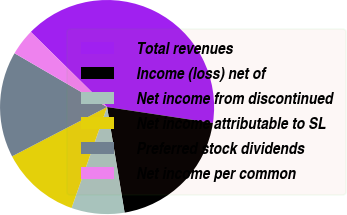Convert chart. <chart><loc_0><loc_0><loc_500><loc_500><pie_chart><fcel>Total revenues<fcel>Income (loss) net of<fcel>Net income from discontinued<fcel>Net income attributable to SL<fcel>Preferred stock dividends<fcel>Net income per common<nl><fcel>40.0%<fcel>20.0%<fcel>8.0%<fcel>12.0%<fcel>16.0%<fcel>4.0%<nl></chart> 